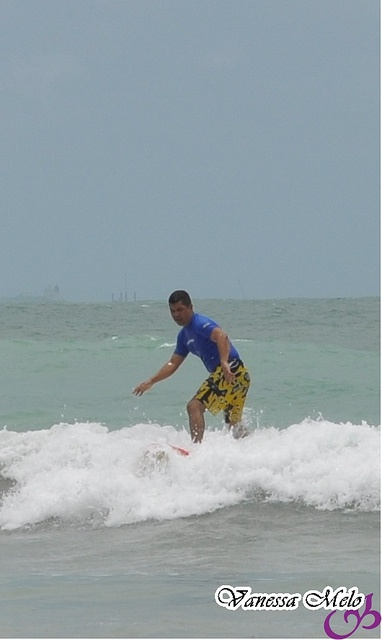Describe the objects in this image and their specific colors. I can see people in darkgray, gray, navy, and olive tones and surfboard in darkgray, lightgray, and salmon tones in this image. 